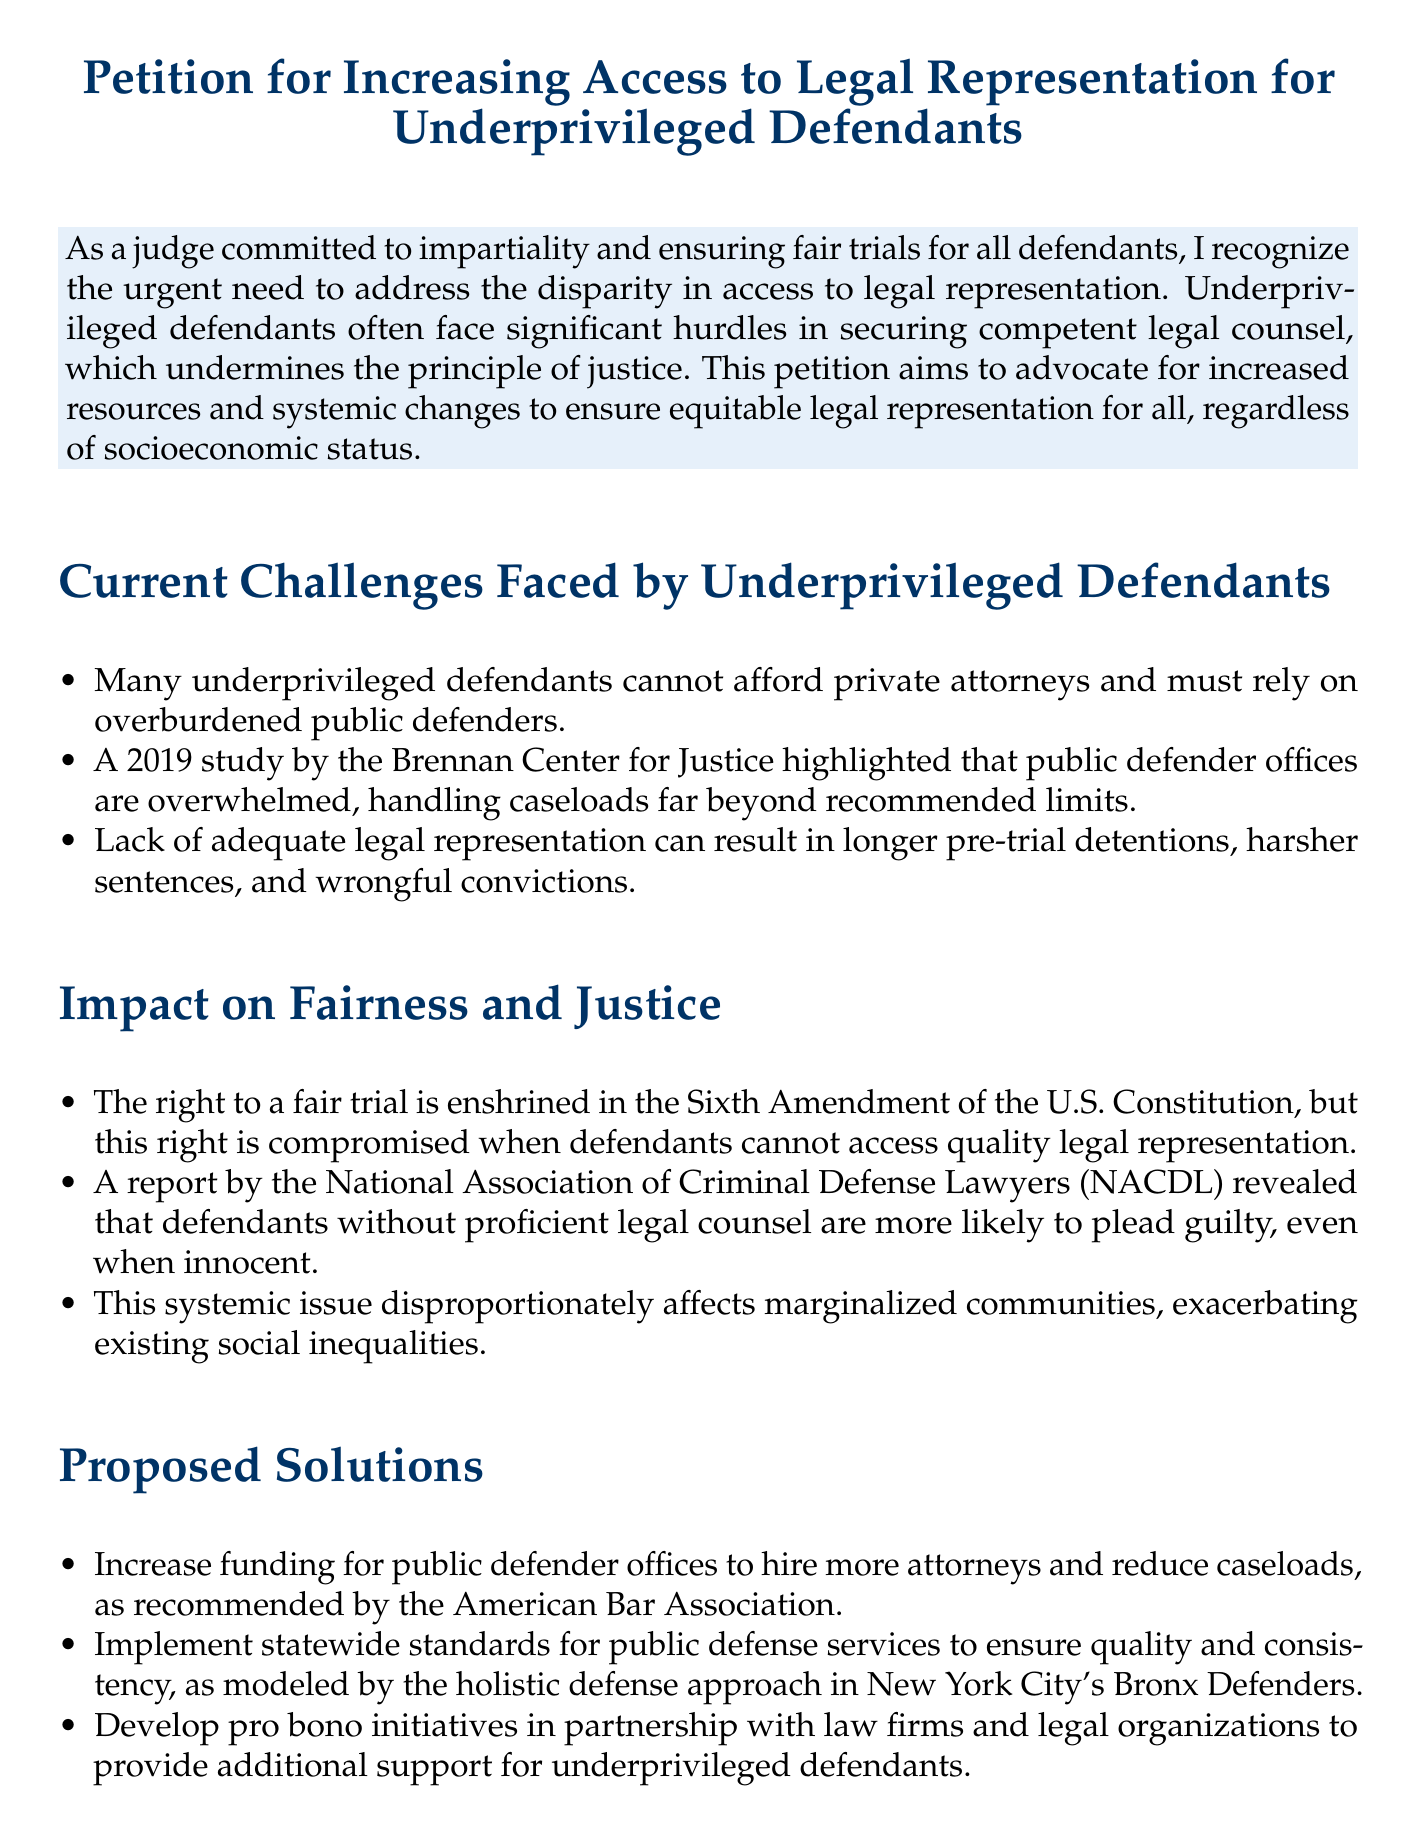What is the title of the petition? The title is clearly stated at the beginning of the document as "Petition for Increasing Access to Legal Representation for Underprivileged Defendants."
Answer: Petition for Increasing Access to Legal Representation for Underprivileged Defendants What year was the study by the Brennan Center for Justice conducted? The year is mentioned in the text discussing the challenges faced by underprivileged defendants.
Answer: 2019 What constitutional amendment is referenced regarding the right to a fair trial? The document specifies that the right is enshrined in the Sixth Amendment.
Answer: Sixth Amendment Which approach is suggested for ensuring quality and consistency in public defense services? The document references a specific model used in New York City's Bronx Defenders.
Answer: holistic defense approach What is one of the proposed solutions to increase legal representation for underprivileged defendants? The document includes several proposed solutions; one specified is to increase funding for public defender offices.
Answer: Increase funding for public defender offices Who is urged to prioritize the initiatives outlined in the petition? The document calls upon specific groups to take action, including policymakers, judicial authorities, and the legal community.
Answer: policymakers, judicial authorities, and the legal community What color is used for the title and signing sections of the document? The color is explicitly mentioned in the formatting sections of the document.
Answer: judgeblue 